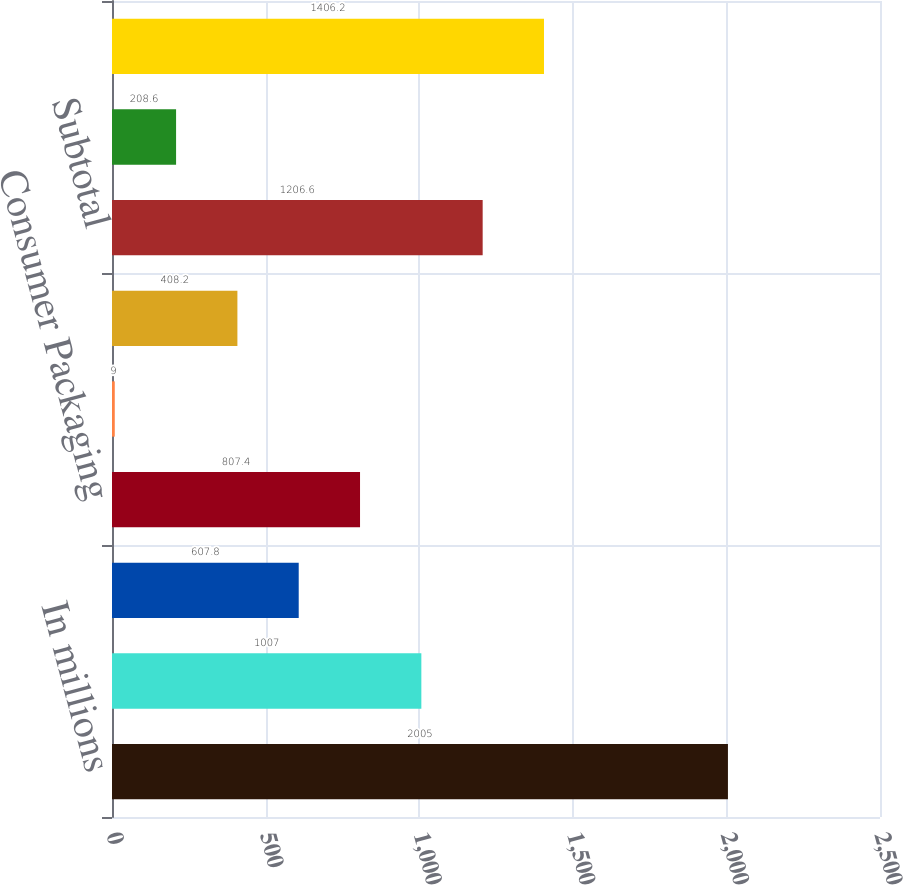Convert chart to OTSL. <chart><loc_0><loc_0><loc_500><loc_500><bar_chart><fcel>In millions<fcel>Printing Papers<fcel>Industrial Packaging<fcel>Consumer Packaging<fcel>Distribution<fcel>Forest Products<fcel>Subtotal<fcel>Corporate and other<fcel>Total from continuing<nl><fcel>2005<fcel>1007<fcel>607.8<fcel>807.4<fcel>9<fcel>408.2<fcel>1206.6<fcel>208.6<fcel>1406.2<nl></chart> 